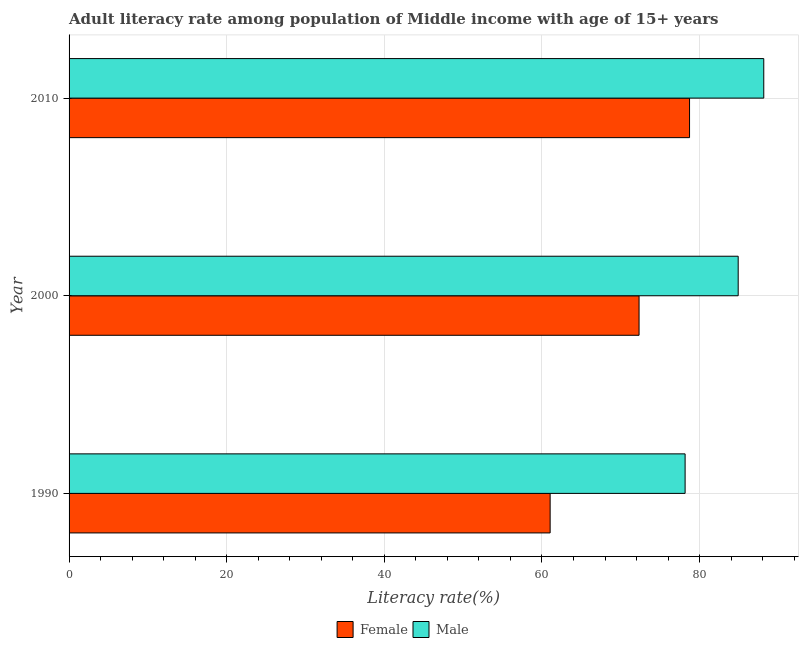Are the number of bars per tick equal to the number of legend labels?
Give a very brief answer. Yes. How many bars are there on the 3rd tick from the bottom?
Give a very brief answer. 2. What is the female adult literacy rate in 1990?
Make the answer very short. 61.04. Across all years, what is the maximum male adult literacy rate?
Ensure brevity in your answer.  88.14. Across all years, what is the minimum male adult literacy rate?
Ensure brevity in your answer.  78.16. In which year was the male adult literacy rate maximum?
Your response must be concise. 2010. What is the total male adult literacy rate in the graph?
Provide a short and direct response. 251.19. What is the difference between the female adult literacy rate in 1990 and that in 2000?
Offer a terse response. -11.28. What is the difference between the female adult literacy rate in 1990 and the male adult literacy rate in 2000?
Make the answer very short. -23.86. What is the average female adult literacy rate per year?
Keep it short and to the point. 70.69. In the year 2000, what is the difference between the female adult literacy rate and male adult literacy rate?
Keep it short and to the point. -12.58. What is the ratio of the female adult literacy rate in 1990 to that in 2000?
Ensure brevity in your answer.  0.84. Is the female adult literacy rate in 1990 less than that in 2010?
Provide a succinct answer. Yes. What is the difference between the highest and the second highest male adult literacy rate?
Offer a very short reply. 3.24. What is the difference between the highest and the lowest female adult literacy rate?
Offer a terse response. 17.69. In how many years, is the female adult literacy rate greater than the average female adult literacy rate taken over all years?
Your answer should be compact. 2. Is the sum of the female adult literacy rate in 1990 and 2000 greater than the maximum male adult literacy rate across all years?
Keep it short and to the point. Yes. What is the difference between two consecutive major ticks on the X-axis?
Your response must be concise. 20. Are the values on the major ticks of X-axis written in scientific E-notation?
Your response must be concise. No. What is the title of the graph?
Make the answer very short. Adult literacy rate among population of Middle income with age of 15+ years. What is the label or title of the X-axis?
Ensure brevity in your answer.  Literacy rate(%). What is the Literacy rate(%) in Female in 1990?
Offer a terse response. 61.04. What is the Literacy rate(%) in Male in 1990?
Provide a short and direct response. 78.16. What is the Literacy rate(%) in Female in 2000?
Ensure brevity in your answer.  72.32. What is the Literacy rate(%) of Male in 2000?
Offer a very short reply. 84.89. What is the Literacy rate(%) in Female in 2010?
Offer a terse response. 78.72. What is the Literacy rate(%) of Male in 2010?
Offer a very short reply. 88.14. Across all years, what is the maximum Literacy rate(%) of Female?
Make the answer very short. 78.72. Across all years, what is the maximum Literacy rate(%) in Male?
Provide a short and direct response. 88.14. Across all years, what is the minimum Literacy rate(%) in Female?
Your response must be concise. 61.04. Across all years, what is the minimum Literacy rate(%) in Male?
Make the answer very short. 78.16. What is the total Literacy rate(%) in Female in the graph?
Your response must be concise. 212.08. What is the total Literacy rate(%) of Male in the graph?
Ensure brevity in your answer.  251.19. What is the difference between the Literacy rate(%) of Female in 1990 and that in 2000?
Your answer should be very brief. -11.28. What is the difference between the Literacy rate(%) in Male in 1990 and that in 2000?
Give a very brief answer. -6.73. What is the difference between the Literacy rate(%) of Female in 1990 and that in 2010?
Your answer should be compact. -17.69. What is the difference between the Literacy rate(%) in Male in 1990 and that in 2010?
Your response must be concise. -9.98. What is the difference between the Literacy rate(%) in Female in 2000 and that in 2010?
Your answer should be very brief. -6.4. What is the difference between the Literacy rate(%) in Male in 2000 and that in 2010?
Provide a succinct answer. -3.24. What is the difference between the Literacy rate(%) in Female in 1990 and the Literacy rate(%) in Male in 2000?
Ensure brevity in your answer.  -23.86. What is the difference between the Literacy rate(%) of Female in 1990 and the Literacy rate(%) of Male in 2010?
Offer a very short reply. -27.1. What is the difference between the Literacy rate(%) in Female in 2000 and the Literacy rate(%) in Male in 2010?
Your response must be concise. -15.82. What is the average Literacy rate(%) of Female per year?
Offer a very short reply. 70.69. What is the average Literacy rate(%) of Male per year?
Provide a succinct answer. 83.73. In the year 1990, what is the difference between the Literacy rate(%) in Female and Literacy rate(%) in Male?
Your answer should be very brief. -17.12. In the year 2000, what is the difference between the Literacy rate(%) in Female and Literacy rate(%) in Male?
Your response must be concise. -12.58. In the year 2010, what is the difference between the Literacy rate(%) of Female and Literacy rate(%) of Male?
Provide a short and direct response. -9.42. What is the ratio of the Literacy rate(%) of Female in 1990 to that in 2000?
Your answer should be very brief. 0.84. What is the ratio of the Literacy rate(%) in Male in 1990 to that in 2000?
Your response must be concise. 0.92. What is the ratio of the Literacy rate(%) in Female in 1990 to that in 2010?
Give a very brief answer. 0.78. What is the ratio of the Literacy rate(%) of Male in 1990 to that in 2010?
Provide a succinct answer. 0.89. What is the ratio of the Literacy rate(%) of Female in 2000 to that in 2010?
Offer a very short reply. 0.92. What is the ratio of the Literacy rate(%) of Male in 2000 to that in 2010?
Provide a succinct answer. 0.96. What is the difference between the highest and the second highest Literacy rate(%) in Female?
Your answer should be compact. 6.4. What is the difference between the highest and the second highest Literacy rate(%) in Male?
Offer a very short reply. 3.24. What is the difference between the highest and the lowest Literacy rate(%) in Female?
Make the answer very short. 17.69. What is the difference between the highest and the lowest Literacy rate(%) of Male?
Offer a very short reply. 9.98. 